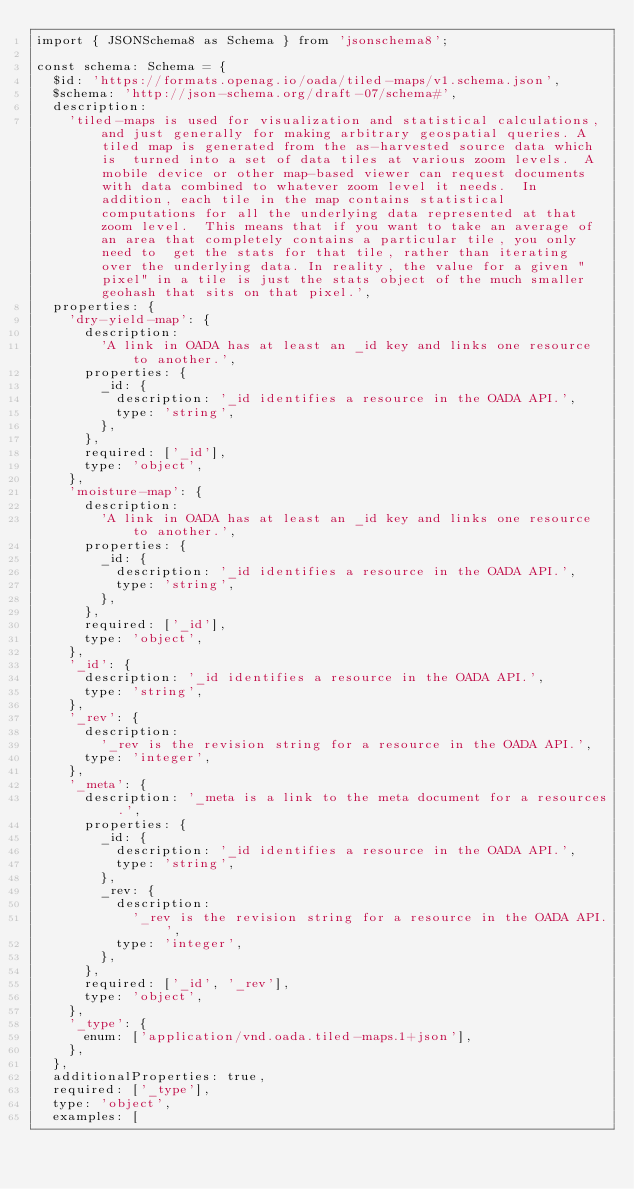Convert code to text. <code><loc_0><loc_0><loc_500><loc_500><_TypeScript_>import { JSONSchema8 as Schema } from 'jsonschema8';

const schema: Schema = {
  $id: 'https://formats.openag.io/oada/tiled-maps/v1.schema.json',
  $schema: 'http://json-schema.org/draft-07/schema#',
  description:
    'tiled-maps is used for visualization and statistical calculations, and just generally for making arbitrary geospatial queries. A tiled map is generated from the as-harvested source data which is  turned into a set of data tiles at various zoom levels.  A mobile device or other map-based viewer can request documents with data combined to whatever zoom level it needs.  In addition, each tile in the map contains statistical computations for all the underlying data represented at that zoom level.  This means that if you want to take an average of an area that completely contains a particular tile, you only need to  get the stats for that tile, rather than iterating over the underlying data. In reality, the value for a given "pixel" in a tile is just the stats object of the much smaller geohash that sits on that pixel.',
  properties: {
    'dry-yield-map': {
      description:
        'A link in OADA has at least an _id key and links one resource to another.',
      properties: {
        _id: {
          description: '_id identifies a resource in the OADA API.',
          type: 'string',
        },
      },
      required: ['_id'],
      type: 'object',
    },
    'moisture-map': {
      description:
        'A link in OADA has at least an _id key and links one resource to another.',
      properties: {
        _id: {
          description: '_id identifies a resource in the OADA API.',
          type: 'string',
        },
      },
      required: ['_id'],
      type: 'object',
    },
    '_id': {
      description: '_id identifies a resource in the OADA API.',
      type: 'string',
    },
    '_rev': {
      description:
        '_rev is the revision string for a resource in the OADA API.',
      type: 'integer',
    },
    '_meta': {
      description: '_meta is a link to the meta document for a resources.',
      properties: {
        _id: {
          description: '_id identifies a resource in the OADA API.',
          type: 'string',
        },
        _rev: {
          description:
            '_rev is the revision string for a resource in the OADA API.',
          type: 'integer',
        },
      },
      required: ['_id', '_rev'],
      type: 'object',
    },
    '_type': {
      enum: ['application/vnd.oada.tiled-maps.1+json'],
    },
  },
  additionalProperties: true,
  required: ['_type'],
  type: 'object',
  examples: [</code> 